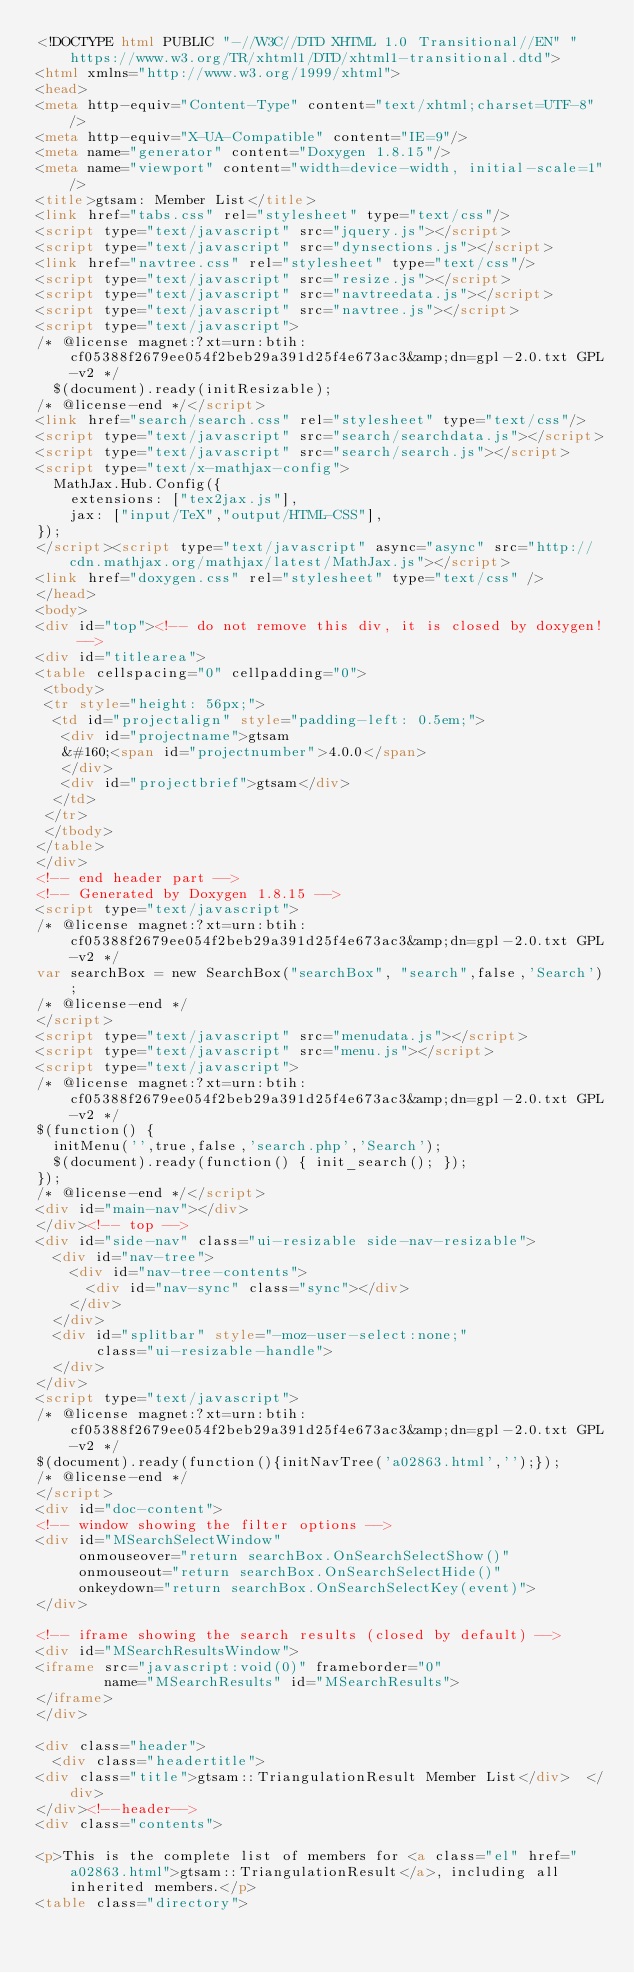<code> <loc_0><loc_0><loc_500><loc_500><_HTML_><!DOCTYPE html PUBLIC "-//W3C//DTD XHTML 1.0 Transitional//EN" "https://www.w3.org/TR/xhtml1/DTD/xhtml1-transitional.dtd">
<html xmlns="http://www.w3.org/1999/xhtml">
<head>
<meta http-equiv="Content-Type" content="text/xhtml;charset=UTF-8"/>
<meta http-equiv="X-UA-Compatible" content="IE=9"/>
<meta name="generator" content="Doxygen 1.8.15"/>
<meta name="viewport" content="width=device-width, initial-scale=1"/>
<title>gtsam: Member List</title>
<link href="tabs.css" rel="stylesheet" type="text/css"/>
<script type="text/javascript" src="jquery.js"></script>
<script type="text/javascript" src="dynsections.js"></script>
<link href="navtree.css" rel="stylesheet" type="text/css"/>
<script type="text/javascript" src="resize.js"></script>
<script type="text/javascript" src="navtreedata.js"></script>
<script type="text/javascript" src="navtree.js"></script>
<script type="text/javascript">
/* @license magnet:?xt=urn:btih:cf05388f2679ee054f2beb29a391d25f4e673ac3&amp;dn=gpl-2.0.txt GPL-v2 */
  $(document).ready(initResizable);
/* @license-end */</script>
<link href="search/search.css" rel="stylesheet" type="text/css"/>
<script type="text/javascript" src="search/searchdata.js"></script>
<script type="text/javascript" src="search/search.js"></script>
<script type="text/x-mathjax-config">
  MathJax.Hub.Config({
    extensions: ["tex2jax.js"],
    jax: ["input/TeX","output/HTML-CSS"],
});
</script><script type="text/javascript" async="async" src="http://cdn.mathjax.org/mathjax/latest/MathJax.js"></script>
<link href="doxygen.css" rel="stylesheet" type="text/css" />
</head>
<body>
<div id="top"><!-- do not remove this div, it is closed by doxygen! -->
<div id="titlearea">
<table cellspacing="0" cellpadding="0">
 <tbody>
 <tr style="height: 56px;">
  <td id="projectalign" style="padding-left: 0.5em;">
   <div id="projectname">gtsam
   &#160;<span id="projectnumber">4.0.0</span>
   </div>
   <div id="projectbrief">gtsam</div>
  </td>
 </tr>
 </tbody>
</table>
</div>
<!-- end header part -->
<!-- Generated by Doxygen 1.8.15 -->
<script type="text/javascript">
/* @license magnet:?xt=urn:btih:cf05388f2679ee054f2beb29a391d25f4e673ac3&amp;dn=gpl-2.0.txt GPL-v2 */
var searchBox = new SearchBox("searchBox", "search",false,'Search');
/* @license-end */
</script>
<script type="text/javascript" src="menudata.js"></script>
<script type="text/javascript" src="menu.js"></script>
<script type="text/javascript">
/* @license magnet:?xt=urn:btih:cf05388f2679ee054f2beb29a391d25f4e673ac3&amp;dn=gpl-2.0.txt GPL-v2 */
$(function() {
  initMenu('',true,false,'search.php','Search');
  $(document).ready(function() { init_search(); });
});
/* @license-end */</script>
<div id="main-nav"></div>
</div><!-- top -->
<div id="side-nav" class="ui-resizable side-nav-resizable">
  <div id="nav-tree">
    <div id="nav-tree-contents">
      <div id="nav-sync" class="sync"></div>
    </div>
  </div>
  <div id="splitbar" style="-moz-user-select:none;" 
       class="ui-resizable-handle">
  </div>
</div>
<script type="text/javascript">
/* @license magnet:?xt=urn:btih:cf05388f2679ee054f2beb29a391d25f4e673ac3&amp;dn=gpl-2.0.txt GPL-v2 */
$(document).ready(function(){initNavTree('a02863.html','');});
/* @license-end */
</script>
<div id="doc-content">
<!-- window showing the filter options -->
<div id="MSearchSelectWindow"
     onmouseover="return searchBox.OnSearchSelectShow()"
     onmouseout="return searchBox.OnSearchSelectHide()"
     onkeydown="return searchBox.OnSearchSelectKey(event)">
</div>

<!-- iframe showing the search results (closed by default) -->
<div id="MSearchResultsWindow">
<iframe src="javascript:void(0)" frameborder="0" 
        name="MSearchResults" id="MSearchResults">
</iframe>
</div>

<div class="header">
  <div class="headertitle">
<div class="title">gtsam::TriangulationResult Member List</div>  </div>
</div><!--header-->
<div class="contents">

<p>This is the complete list of members for <a class="el" href="a02863.html">gtsam::TriangulationResult</a>, including all inherited members.</p>
<table class="directory"></code> 